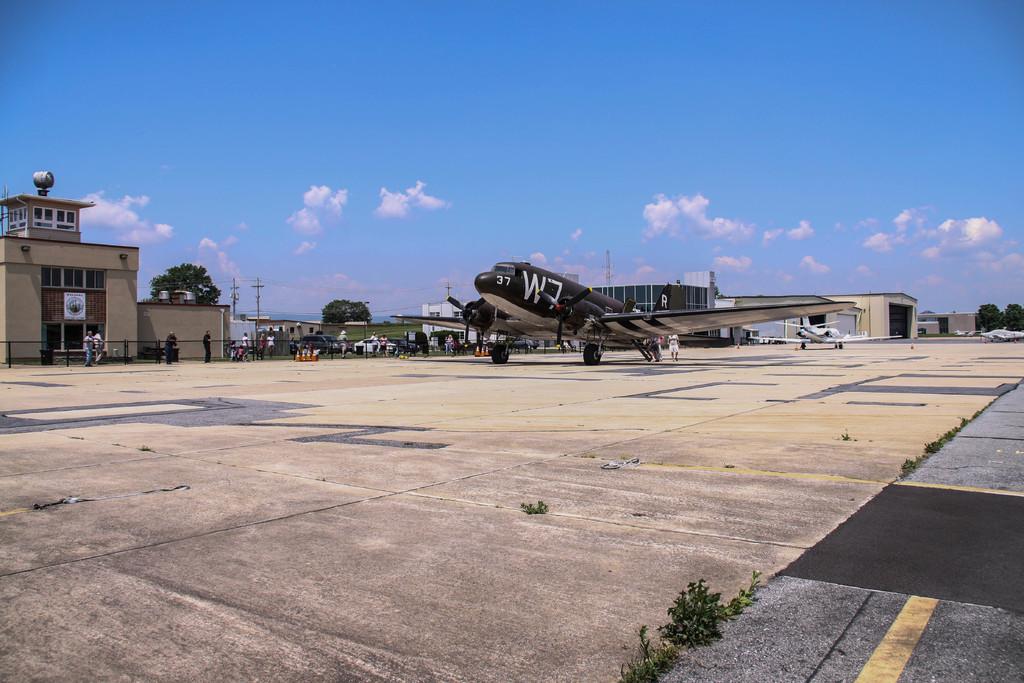What is the text on the airplane?
Offer a very short reply. W7. 